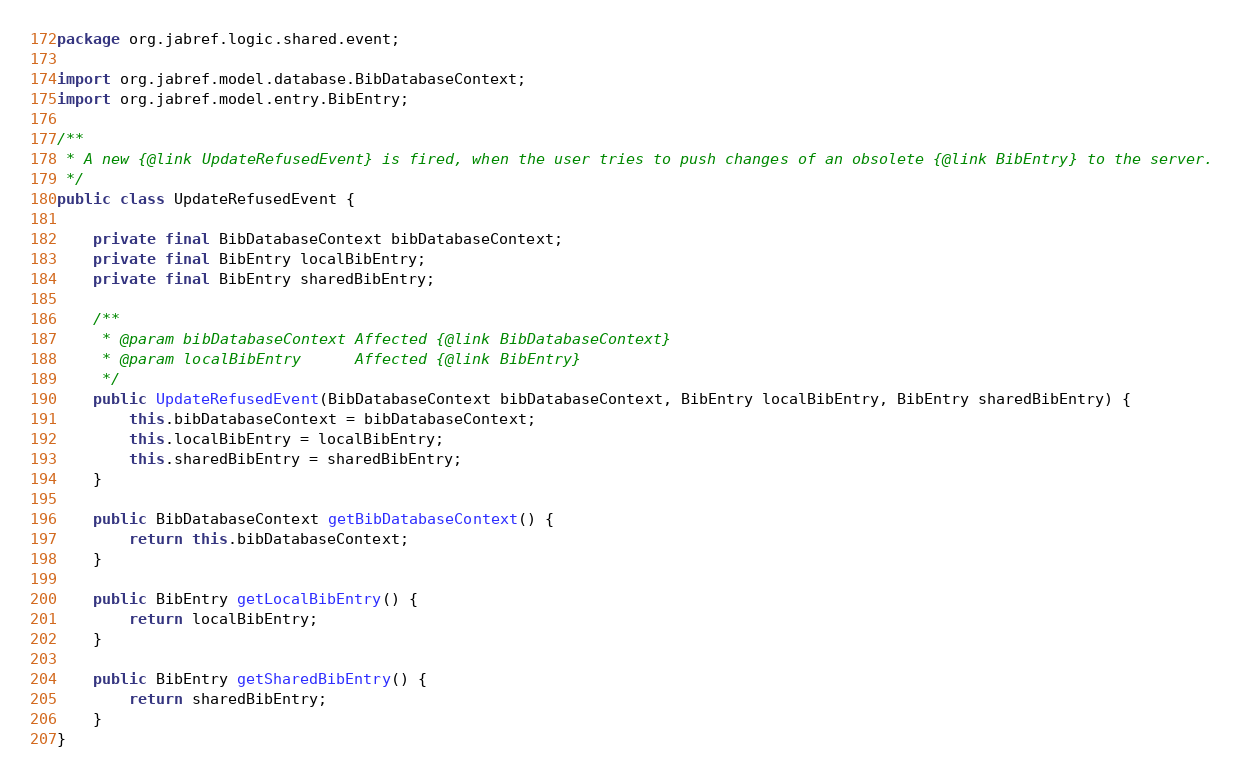Convert code to text. <code><loc_0><loc_0><loc_500><loc_500><_Java_>package org.jabref.logic.shared.event;

import org.jabref.model.database.BibDatabaseContext;
import org.jabref.model.entry.BibEntry;

/**
 * A new {@link UpdateRefusedEvent} is fired, when the user tries to push changes of an obsolete {@link BibEntry} to the server.
 */
public class UpdateRefusedEvent {

    private final BibDatabaseContext bibDatabaseContext;
    private final BibEntry localBibEntry;
    private final BibEntry sharedBibEntry;

    /**
     * @param bibDatabaseContext Affected {@link BibDatabaseContext}
     * @param localBibEntry      Affected {@link BibEntry}
     */
    public UpdateRefusedEvent(BibDatabaseContext bibDatabaseContext, BibEntry localBibEntry, BibEntry sharedBibEntry) {
        this.bibDatabaseContext = bibDatabaseContext;
        this.localBibEntry = localBibEntry;
        this.sharedBibEntry = sharedBibEntry;
    }

    public BibDatabaseContext getBibDatabaseContext() {
        return this.bibDatabaseContext;
    }

    public BibEntry getLocalBibEntry() {
        return localBibEntry;
    }

    public BibEntry getSharedBibEntry() {
        return sharedBibEntry;
    }
}
</code> 